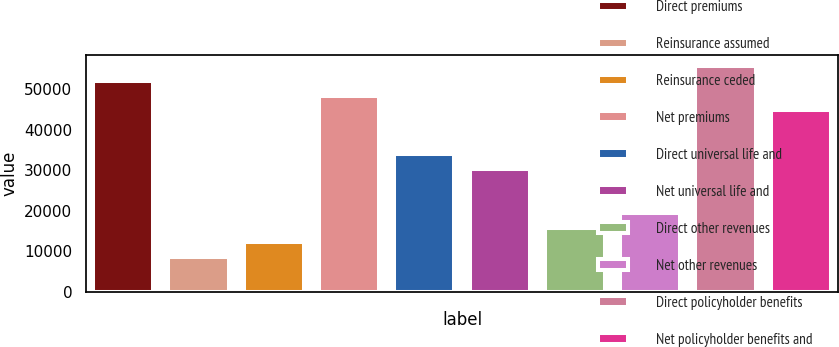<chart> <loc_0><loc_0><loc_500><loc_500><bar_chart><fcel>Direct premiums<fcel>Reinsurance assumed<fcel>Reinsurance ceded<fcel>Net premiums<fcel>Direct universal life and<fcel>Net universal life and<fcel>Direct other revenues<fcel>Net other revenues<fcel>Direct policyholder benefits<fcel>Net policyholder benefits and<nl><fcel>52025.2<fcel>8671.6<fcel>12284.4<fcel>48412.4<fcel>33961.2<fcel>30348.4<fcel>15897.2<fcel>19510<fcel>55638<fcel>44799.6<nl></chart> 